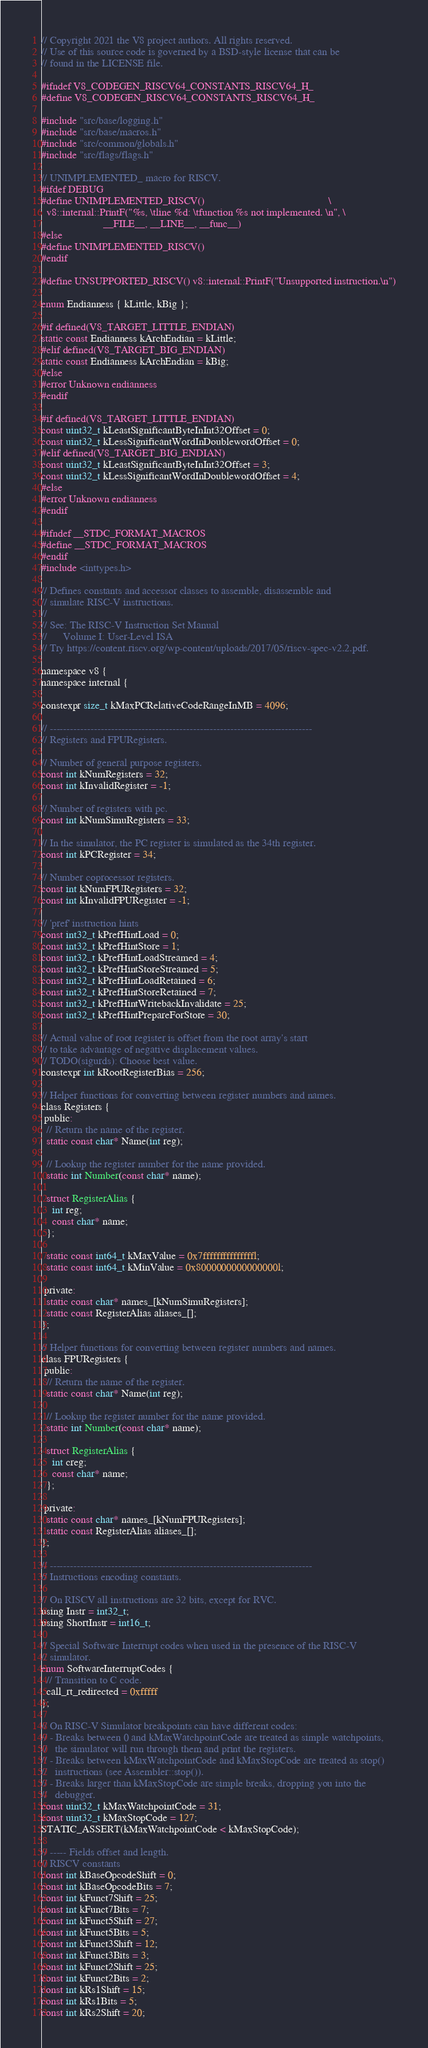Convert code to text. <code><loc_0><loc_0><loc_500><loc_500><_C_>// Copyright 2021 the V8 project authors. All rights reserved.
// Use of this source code is governed by a BSD-style license that can be
// found in the LICENSE file.

#ifndef V8_CODEGEN_RISCV64_CONSTANTS_RISCV64_H_
#define V8_CODEGEN_RISCV64_CONSTANTS_RISCV64_H_

#include "src/base/logging.h"
#include "src/base/macros.h"
#include "src/common/globals.h"
#include "src/flags/flags.h"

// UNIMPLEMENTED_ macro for RISCV.
#ifdef DEBUG
#define UNIMPLEMENTED_RISCV()                                              \
  v8::internal::PrintF("%s, \tline %d: \tfunction %s not implemented. \n", \
                       __FILE__, __LINE__, __func__)
#else
#define UNIMPLEMENTED_RISCV()
#endif

#define UNSUPPORTED_RISCV() v8::internal::PrintF("Unsupported instruction.\n")

enum Endianness { kLittle, kBig };

#if defined(V8_TARGET_LITTLE_ENDIAN)
static const Endianness kArchEndian = kLittle;
#elif defined(V8_TARGET_BIG_ENDIAN)
static const Endianness kArchEndian = kBig;
#else
#error Unknown endianness
#endif

#if defined(V8_TARGET_LITTLE_ENDIAN)
const uint32_t kLeastSignificantByteInInt32Offset = 0;
const uint32_t kLessSignificantWordInDoublewordOffset = 0;
#elif defined(V8_TARGET_BIG_ENDIAN)
const uint32_t kLeastSignificantByteInInt32Offset = 3;
const uint32_t kLessSignificantWordInDoublewordOffset = 4;
#else
#error Unknown endianness
#endif

#ifndef __STDC_FORMAT_MACROS
#define __STDC_FORMAT_MACROS
#endif
#include <inttypes.h>

// Defines constants and accessor classes to assemble, disassemble and
// simulate RISC-V instructions.
//
// See: The RISC-V Instruction Set Manual
//      Volume I: User-Level ISA
// Try https://content.riscv.org/wp-content/uploads/2017/05/riscv-spec-v2.2.pdf.

namespace v8 {
namespace internal {

constexpr size_t kMaxPCRelativeCodeRangeInMB = 4096;

// -----------------------------------------------------------------------------
// Registers and FPURegisters.

// Number of general purpose registers.
const int kNumRegisters = 32;
const int kInvalidRegister = -1;

// Number of registers with pc.
const int kNumSimuRegisters = 33;

// In the simulator, the PC register is simulated as the 34th register.
const int kPCRegister = 34;

// Number coprocessor registers.
const int kNumFPURegisters = 32;
const int kInvalidFPURegister = -1;

// 'pref' instruction hints
const int32_t kPrefHintLoad = 0;
const int32_t kPrefHintStore = 1;
const int32_t kPrefHintLoadStreamed = 4;
const int32_t kPrefHintStoreStreamed = 5;
const int32_t kPrefHintLoadRetained = 6;
const int32_t kPrefHintStoreRetained = 7;
const int32_t kPrefHintWritebackInvalidate = 25;
const int32_t kPrefHintPrepareForStore = 30;

// Actual value of root register is offset from the root array's start
// to take advantage of negative displacement values.
// TODO(sigurds): Choose best value.
constexpr int kRootRegisterBias = 256;

// Helper functions for converting between register numbers and names.
class Registers {
 public:
  // Return the name of the register.
  static const char* Name(int reg);

  // Lookup the register number for the name provided.
  static int Number(const char* name);

  struct RegisterAlias {
    int reg;
    const char* name;
  };

  static const int64_t kMaxValue = 0x7fffffffffffffffl;
  static const int64_t kMinValue = 0x8000000000000000l;

 private:
  static const char* names_[kNumSimuRegisters];
  static const RegisterAlias aliases_[];
};

// Helper functions for converting between register numbers and names.
class FPURegisters {
 public:
  // Return the name of the register.
  static const char* Name(int reg);

  // Lookup the register number for the name provided.
  static int Number(const char* name);

  struct RegisterAlias {
    int creg;
    const char* name;
  };

 private:
  static const char* names_[kNumFPURegisters];
  static const RegisterAlias aliases_[];
};

// -----------------------------------------------------------------------------
// Instructions encoding constants.

// On RISCV all instructions are 32 bits, except for RVC.
using Instr = int32_t;
using ShortInstr = int16_t;

// Special Software Interrupt codes when used in the presence of the RISC-V
// simulator.
enum SoftwareInterruptCodes {
  // Transition to C code.
  call_rt_redirected = 0xfffff
};

// On RISC-V Simulator breakpoints can have different codes:
// - Breaks between 0 and kMaxWatchpointCode are treated as simple watchpoints,
//   the simulator will run through them and print the registers.
// - Breaks between kMaxWatchpointCode and kMaxStopCode are treated as stop()
//   instructions (see Assembler::stop()).
// - Breaks larger than kMaxStopCode are simple breaks, dropping you into the
//   debugger.
const uint32_t kMaxWatchpointCode = 31;
const uint32_t kMaxStopCode = 127;
STATIC_ASSERT(kMaxWatchpointCode < kMaxStopCode);

// ----- Fields offset and length.
// RISCV constants
const int kBaseOpcodeShift = 0;
const int kBaseOpcodeBits = 7;
const int kFunct7Shift = 25;
const int kFunct7Bits = 7;
const int kFunct5Shift = 27;
const int kFunct5Bits = 5;
const int kFunct3Shift = 12;
const int kFunct3Bits = 3;
const int kFunct2Shift = 25;
const int kFunct2Bits = 2;
const int kRs1Shift = 15;
const int kRs1Bits = 5;
const int kRs2Shift = 20;</code> 